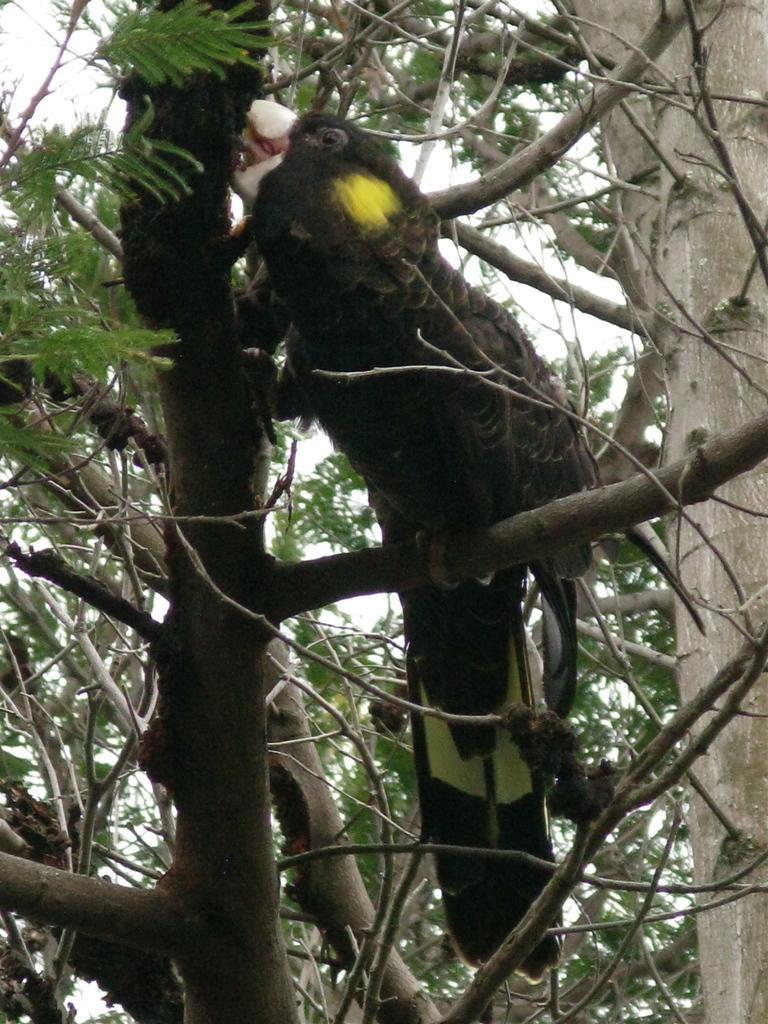Could you give a brief overview of what you see in this image? In the image we can see a tree, on the tree there is a bird. Behind the tree there is sky. 